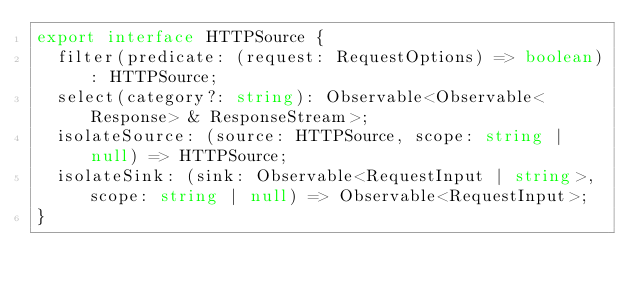<code> <loc_0><loc_0><loc_500><loc_500><_TypeScript_>export interface HTTPSource {
  filter(predicate: (request: RequestOptions) => boolean): HTTPSource;
  select(category?: string): Observable<Observable<Response> & ResponseStream>;
  isolateSource: (source: HTTPSource, scope: string | null) => HTTPSource;
  isolateSink: (sink: Observable<RequestInput | string>, scope: string | null) => Observable<RequestInput>;
}</code> 